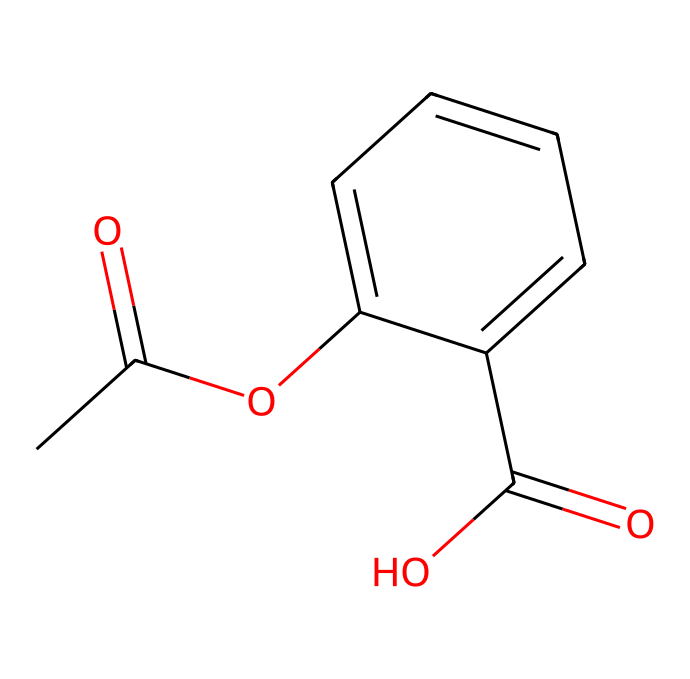What is the molecular formula of this compound? To find the molecular formula, we count the atoms of each element in the structure represented by the SMILES notation. In this case, there are 10 carbon (C) atoms, 10 hydrogen (H) atoms, and 4 oxygen (O) atoms. The molecular formula is thus C10H10O4.
Answer: C10H10O4 How many rings are present in this structure? By examining the structure, we can see that there is one cyclic component (a ring) indicated by the "C1" and "C" notation in the SMILES. Therefore, there is a single ring present in this compound.
Answer: 1 Is this compound a type of ester? The presence of the "CC(=O)O" fragment indicates a functional group involving a carbonyl bonded to an oxygen (ester). This confirms that the compound has an ester functional group, signifying it is indeed an ester.
Answer: Yes What property of this drug makes it effective in treating sports injuries? The compound includes both a carboxylic acid and an ester, which often relates to anti-inflammatory properties as seen in similar chemicals. The functional groups are key to the drug's therapeutic effects and pain relief in sports injuries.
Answer: Anti-inflammatory How does the presence of oxygen influence this compound’s solubility? Oxygen atoms in functional groups like esters and carboxylic acids increase the polarity of the molecule. This generally enhances solubility in polar solvents such as water, making the drug more effective within the biological system for treating injuries.
Answer: Increased solubility 